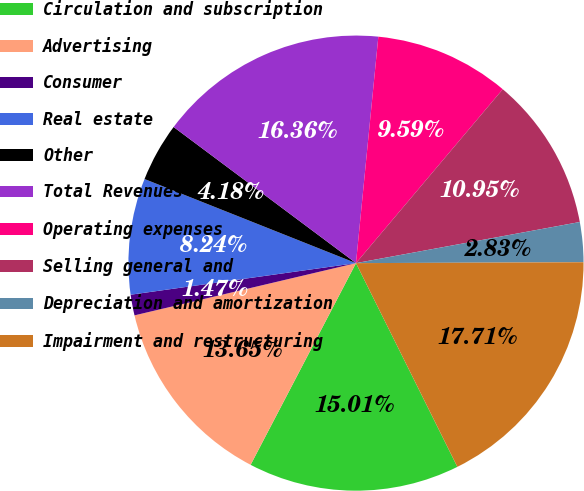Convert chart to OTSL. <chart><loc_0><loc_0><loc_500><loc_500><pie_chart><fcel>Circulation and subscription<fcel>Advertising<fcel>Consumer<fcel>Real estate<fcel>Other<fcel>Total Revenues<fcel>Operating expenses<fcel>Selling general and<fcel>Depreciation and amortization<fcel>Impairment and restructuring<nl><fcel>15.01%<fcel>13.65%<fcel>1.47%<fcel>8.24%<fcel>4.18%<fcel>16.36%<fcel>9.59%<fcel>10.95%<fcel>2.83%<fcel>17.71%<nl></chart> 